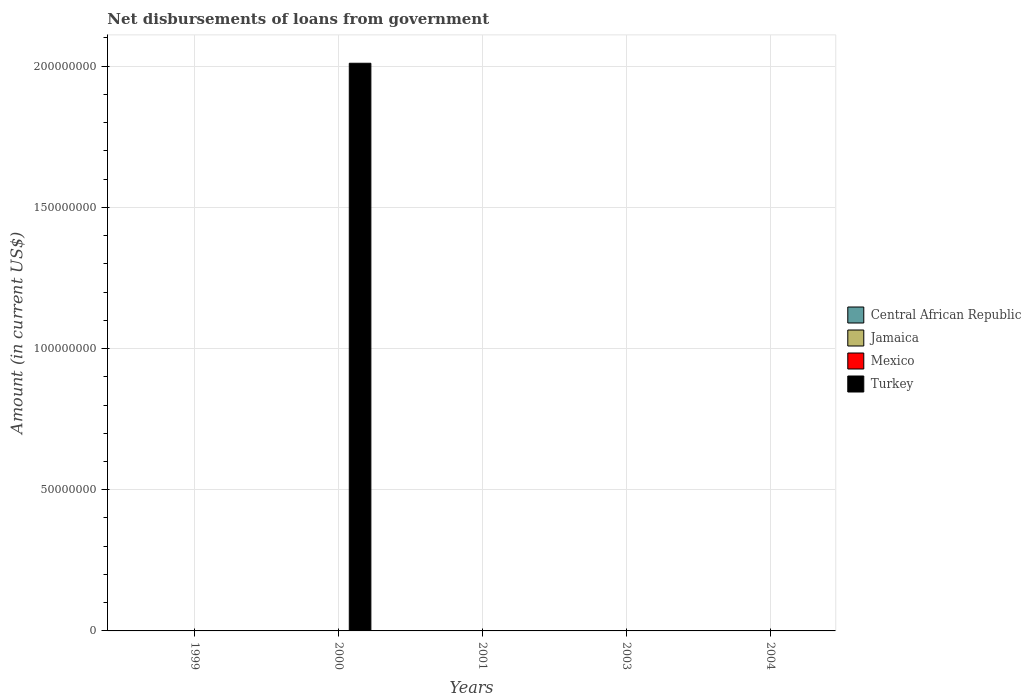How many different coloured bars are there?
Make the answer very short. 1. Are the number of bars per tick equal to the number of legend labels?
Provide a succinct answer. No. How many bars are there on the 1st tick from the left?
Ensure brevity in your answer.  0. How many bars are there on the 4th tick from the right?
Your answer should be very brief. 1. In how many cases, is the number of bars for a given year not equal to the number of legend labels?
Give a very brief answer. 5. What is the amount of loan disbursed from government in Turkey in 2000?
Provide a succinct answer. 2.01e+08. Across all years, what is the maximum amount of loan disbursed from government in Turkey?
Your response must be concise. 2.01e+08. Across all years, what is the minimum amount of loan disbursed from government in Turkey?
Offer a terse response. 0. What is the difference between the amount of loan disbursed from government in Jamaica in 2000 and the amount of loan disbursed from government in Mexico in 2001?
Make the answer very short. 0. What is the difference between the highest and the lowest amount of loan disbursed from government in Turkey?
Give a very brief answer. 2.01e+08. In how many years, is the amount of loan disbursed from government in Mexico greater than the average amount of loan disbursed from government in Mexico taken over all years?
Give a very brief answer. 0. Are all the bars in the graph horizontal?
Give a very brief answer. No. How many years are there in the graph?
Offer a terse response. 5. What is the difference between two consecutive major ticks on the Y-axis?
Make the answer very short. 5.00e+07. Does the graph contain any zero values?
Your answer should be compact. Yes. Where does the legend appear in the graph?
Give a very brief answer. Center right. How are the legend labels stacked?
Ensure brevity in your answer.  Vertical. What is the title of the graph?
Give a very brief answer. Net disbursements of loans from government. What is the label or title of the X-axis?
Your response must be concise. Years. What is the label or title of the Y-axis?
Ensure brevity in your answer.  Amount (in current US$). What is the Amount (in current US$) of Central African Republic in 1999?
Provide a short and direct response. 0. What is the Amount (in current US$) in Mexico in 1999?
Offer a terse response. 0. What is the Amount (in current US$) of Turkey in 1999?
Your response must be concise. 0. What is the Amount (in current US$) of Central African Republic in 2000?
Your answer should be very brief. 0. What is the Amount (in current US$) in Mexico in 2000?
Make the answer very short. 0. What is the Amount (in current US$) in Turkey in 2000?
Offer a very short reply. 2.01e+08. What is the Amount (in current US$) in Central African Republic in 2004?
Your response must be concise. 0. What is the Amount (in current US$) of Turkey in 2004?
Provide a short and direct response. 0. Across all years, what is the maximum Amount (in current US$) of Turkey?
Provide a short and direct response. 2.01e+08. What is the total Amount (in current US$) in Jamaica in the graph?
Provide a succinct answer. 0. What is the total Amount (in current US$) in Mexico in the graph?
Provide a succinct answer. 0. What is the total Amount (in current US$) in Turkey in the graph?
Offer a very short reply. 2.01e+08. What is the average Amount (in current US$) in Jamaica per year?
Offer a terse response. 0. What is the average Amount (in current US$) of Mexico per year?
Give a very brief answer. 0. What is the average Amount (in current US$) in Turkey per year?
Provide a short and direct response. 4.02e+07. What is the difference between the highest and the lowest Amount (in current US$) in Turkey?
Your answer should be very brief. 2.01e+08. 